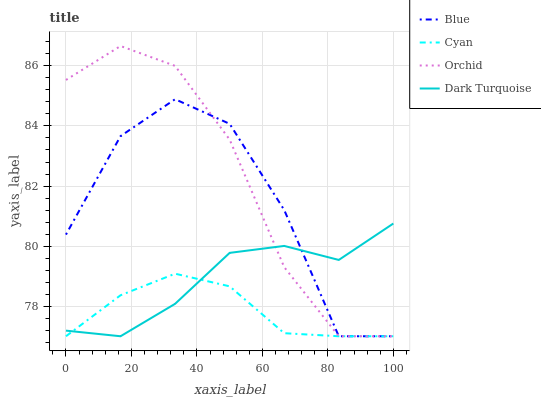Does Cyan have the minimum area under the curve?
Answer yes or no. Yes. Does Orchid have the maximum area under the curve?
Answer yes or no. Yes. Does Dark Turquoise have the minimum area under the curve?
Answer yes or no. No. Does Dark Turquoise have the maximum area under the curve?
Answer yes or no. No. Is Cyan the smoothest?
Answer yes or no. Yes. Is Blue the roughest?
Answer yes or no. Yes. Is Dark Turquoise the smoothest?
Answer yes or no. No. Is Dark Turquoise the roughest?
Answer yes or no. No. Does Blue have the lowest value?
Answer yes or no. Yes. Does Orchid have the highest value?
Answer yes or no. Yes. Does Dark Turquoise have the highest value?
Answer yes or no. No. Does Orchid intersect Cyan?
Answer yes or no. Yes. Is Orchid less than Cyan?
Answer yes or no. No. Is Orchid greater than Cyan?
Answer yes or no. No. 